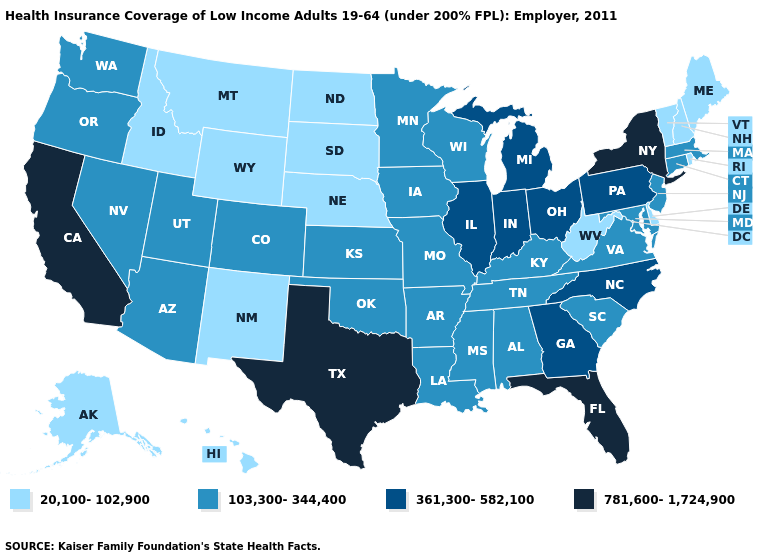Name the states that have a value in the range 361,300-582,100?
Give a very brief answer. Georgia, Illinois, Indiana, Michigan, North Carolina, Ohio, Pennsylvania. Among the states that border Oregon , which have the highest value?
Answer briefly. California. Does the first symbol in the legend represent the smallest category?
Be succinct. Yes. What is the value of Kentucky?
Concise answer only. 103,300-344,400. Which states have the lowest value in the Northeast?
Write a very short answer. Maine, New Hampshire, Rhode Island, Vermont. How many symbols are there in the legend?
Concise answer only. 4. What is the value of West Virginia?
Write a very short answer. 20,100-102,900. What is the value of Texas?
Answer briefly. 781,600-1,724,900. Does the first symbol in the legend represent the smallest category?
Give a very brief answer. Yes. What is the value of Oregon?
Be succinct. 103,300-344,400. Does Nebraska have the lowest value in the USA?
Write a very short answer. Yes. What is the value of Indiana?
Quick response, please. 361,300-582,100. Does the first symbol in the legend represent the smallest category?
Short answer required. Yes. Does the map have missing data?
Concise answer only. No. Name the states that have a value in the range 781,600-1,724,900?
Write a very short answer. California, Florida, New York, Texas. 